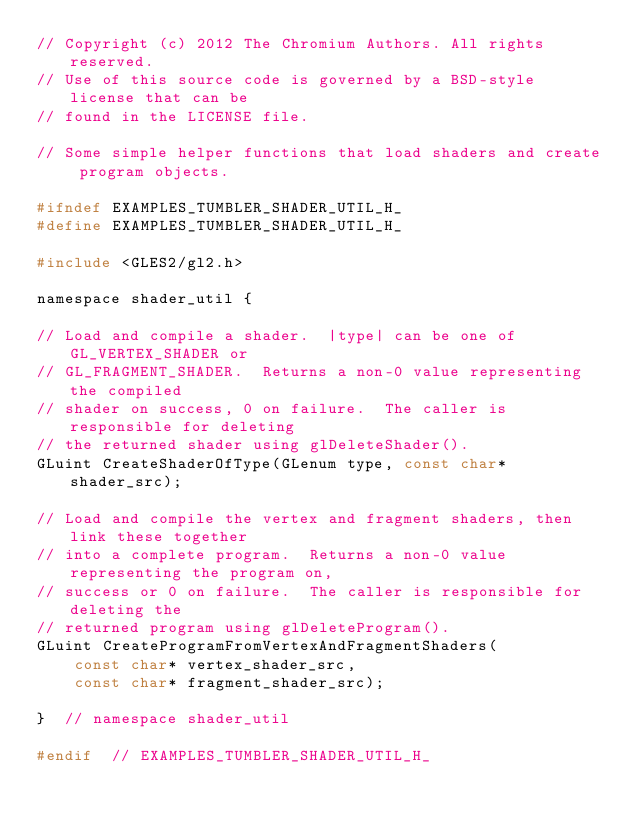<code> <loc_0><loc_0><loc_500><loc_500><_C_>// Copyright (c) 2012 The Chromium Authors. All rights reserved.
// Use of this source code is governed by a BSD-style license that can be
// found in the LICENSE file.

// Some simple helper functions that load shaders and create program objects.

#ifndef EXAMPLES_TUMBLER_SHADER_UTIL_H_
#define EXAMPLES_TUMBLER_SHADER_UTIL_H_

#include <GLES2/gl2.h>

namespace shader_util {

// Load and compile a shader.  |type| can be one of GL_VERTEX_SHADER or
// GL_FRAGMENT_SHADER.  Returns a non-0 value representing the compiled
// shader on success, 0 on failure.  The caller is responsible for deleting
// the returned shader using glDeleteShader().
GLuint CreateShaderOfType(GLenum type, const char* shader_src);

// Load and compile the vertex and fragment shaders, then link these together
// into a complete program.  Returns a non-0 value representing the program on,
// success or 0 on failure.  The caller is responsible for deleting the
// returned program using glDeleteProgram().
GLuint CreateProgramFromVertexAndFragmentShaders(
    const char* vertex_shader_src,
    const char* fragment_shader_src);

}  // namespace shader_util

#endif  // EXAMPLES_TUMBLER_SHADER_UTIL_H_
</code> 